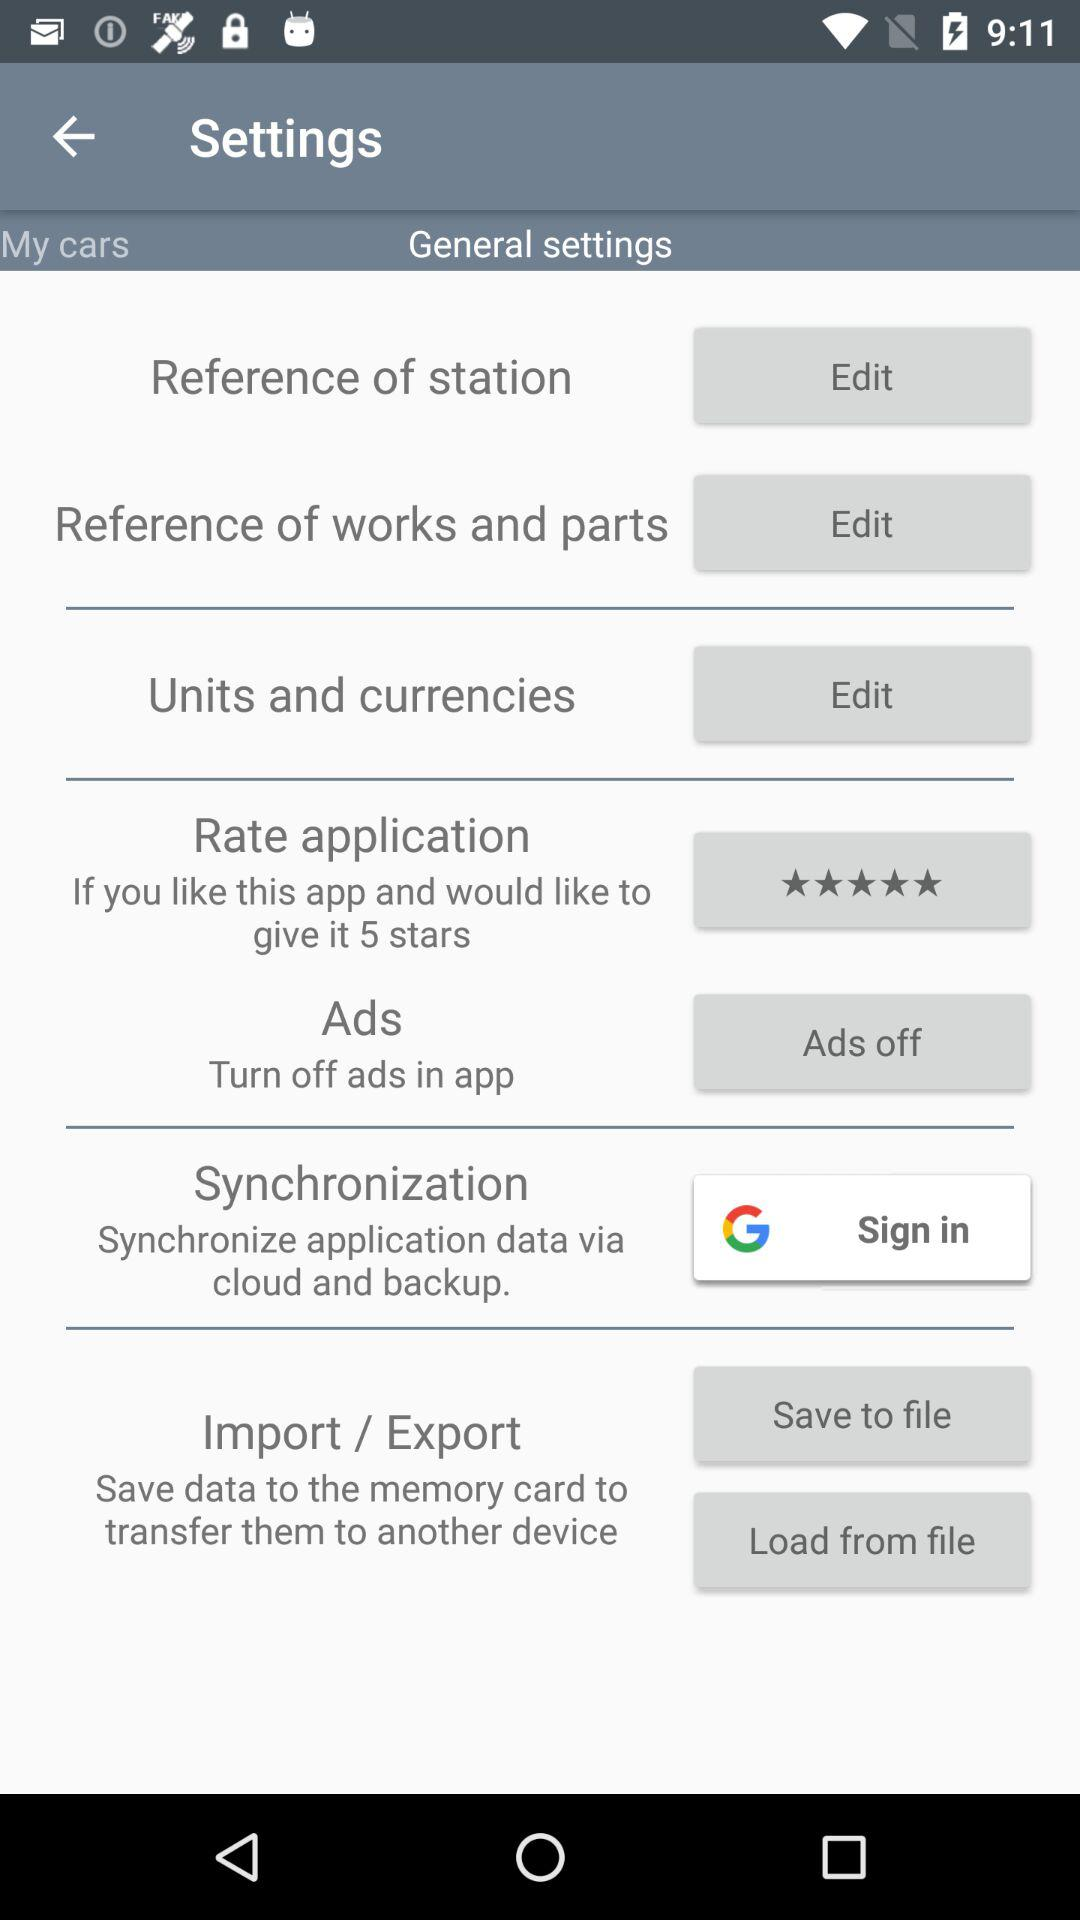What are the ratings?
When the provided information is insufficient, respond with <no answer>. <no answer> 